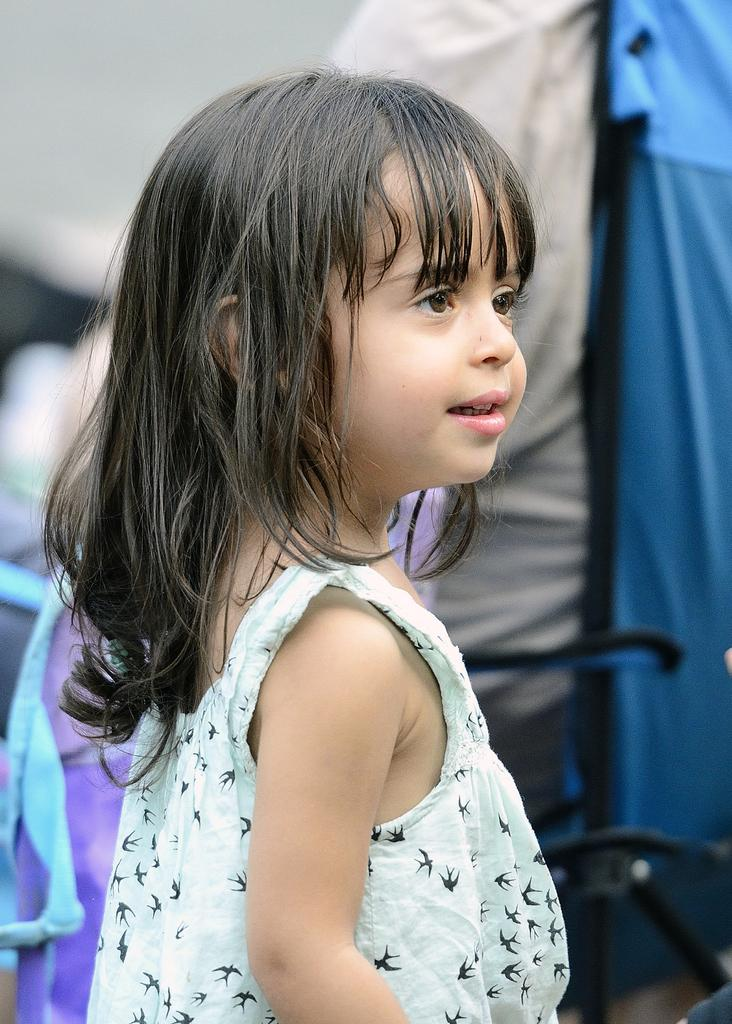Who is the main subject in the image? There is a girl in the image. What is the girl doing in the image? The girl is standing and smiling. Which direction is the girl looking in the image? The girl is looking to the right. What can be seen in the background of the image? There are clothes and a chair in the background of the image. What type of dinosaur can be seen in the image? There are no dinosaurs present in the image; it features a girl standing and smiling. What is the current being used for in the image? There is no mention of a current or any electrical devices in the image. 